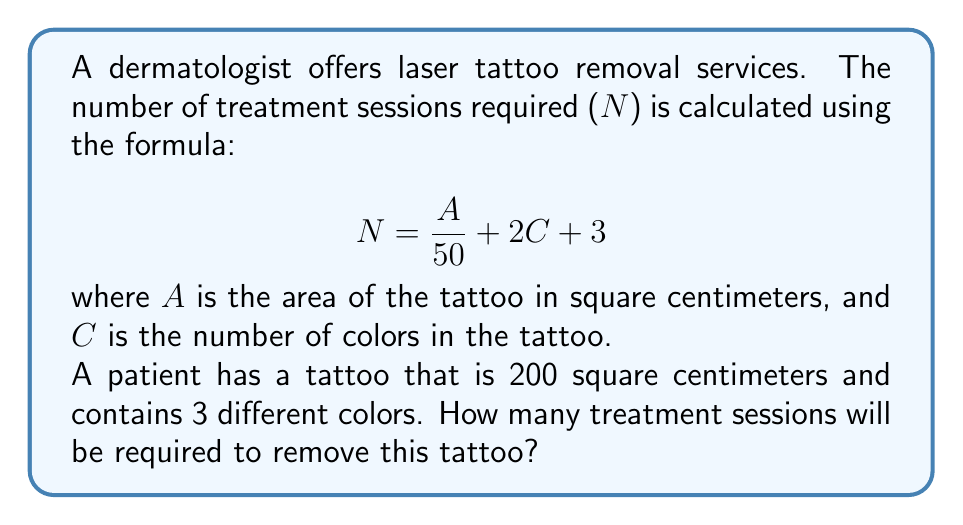Solve this math problem. To solve this problem, we'll use the given formula and plug in the known values:

1) The formula is: $N = \frac{A}{50} + 2C + 3$

2) We know:
   $A = 200$ cm² (area of the tattoo)
   $C = 3$ (number of colors)

3) Let's substitute these values into the formula:

   $$N = \frac{200}{50} + 2(3) + 3$$

4) First, let's calculate $\frac{200}{50}$:
   $$\frac{200}{50} = 4$$

5) Now, let's calculate $2(3)$:
   $$2(3) = 6$$

6) Substituting these results back into the equation:

   $$N = 4 + 6 + 3$$

7) Finally, we can add these numbers:

   $$N = 13$$

Therefore, 13 treatment sessions will be required to remove this tattoo.
Answer: 13 sessions 